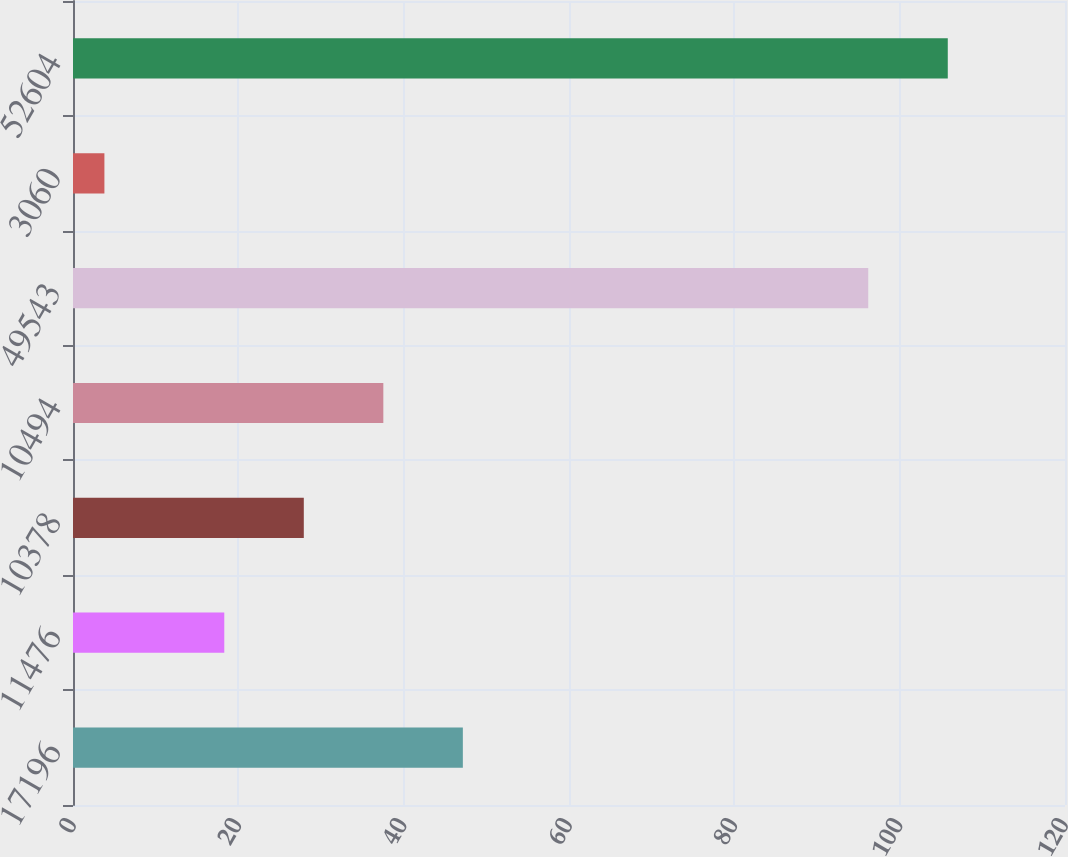Convert chart. <chart><loc_0><loc_0><loc_500><loc_500><bar_chart><fcel>17196<fcel>11476<fcel>10378<fcel>10494<fcel>49543<fcel>3060<fcel>52604<nl><fcel>47.16<fcel>18.3<fcel>27.92<fcel>37.54<fcel>96.2<fcel>3.8<fcel>105.82<nl></chart> 